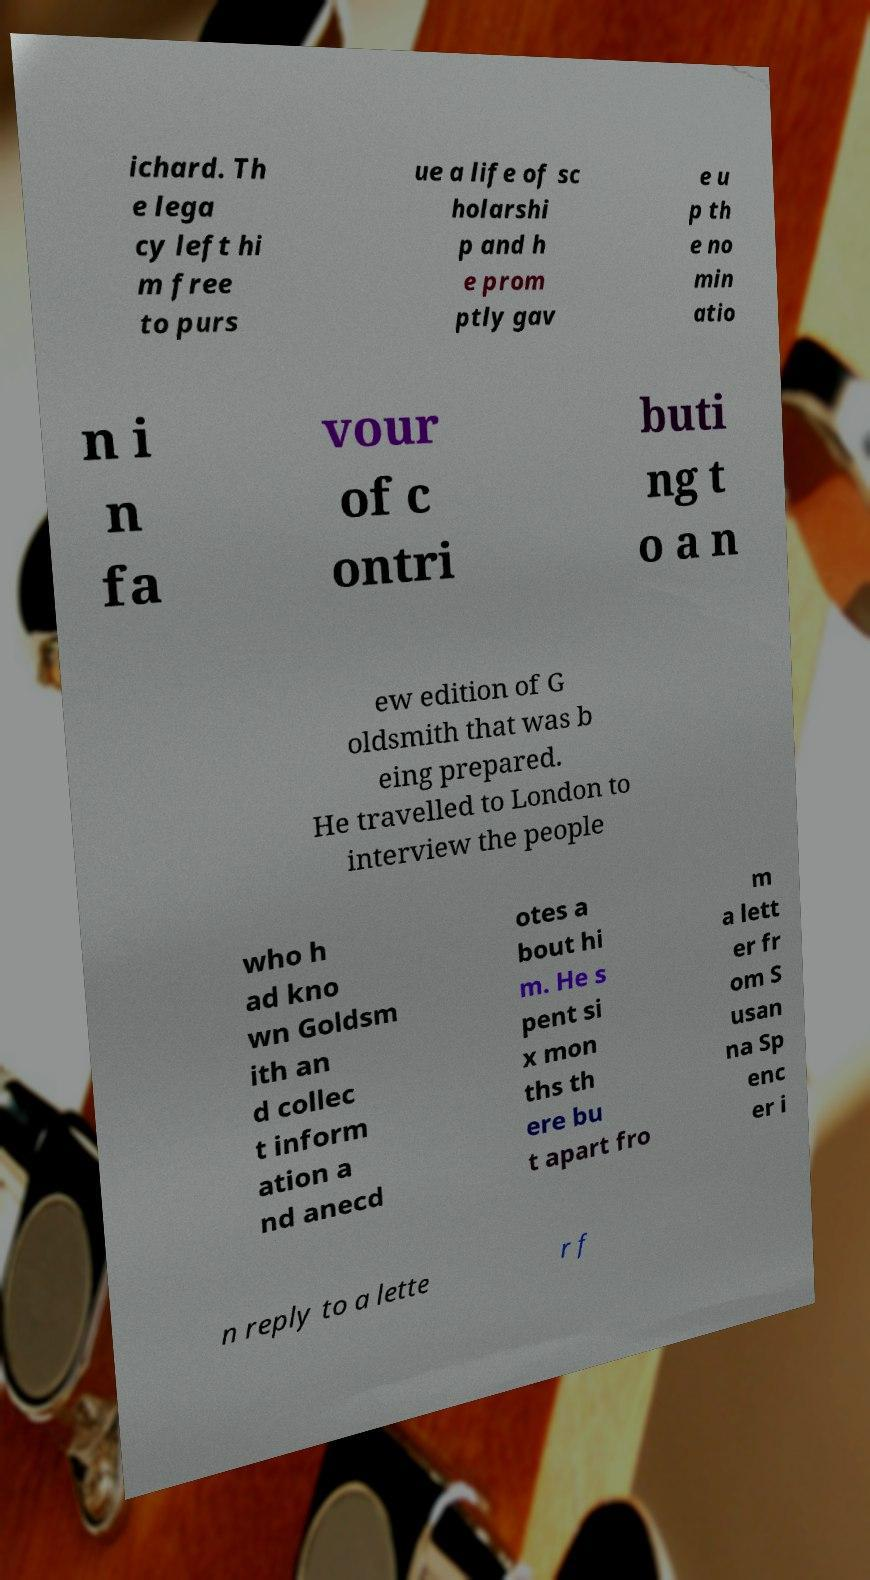Can you accurately transcribe the text from the provided image for me? ichard. Th e lega cy left hi m free to purs ue a life of sc holarshi p and h e prom ptly gav e u p th e no min atio n i n fa vour of c ontri buti ng t o a n ew edition of G oldsmith that was b eing prepared. He travelled to London to interview the people who h ad kno wn Goldsm ith an d collec t inform ation a nd anecd otes a bout hi m. He s pent si x mon ths th ere bu t apart fro m a lett er fr om S usan na Sp enc er i n reply to a lette r f 